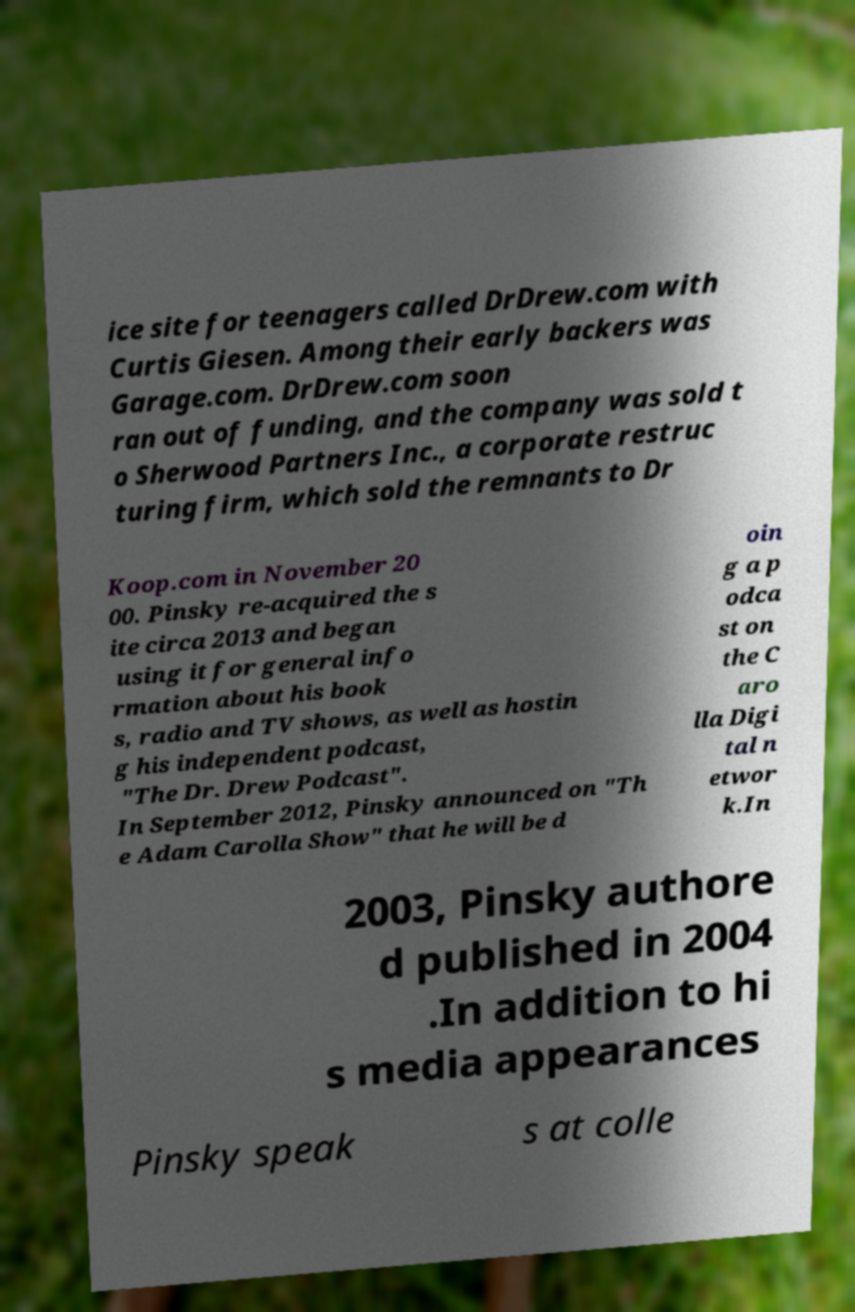Could you assist in decoding the text presented in this image and type it out clearly? ice site for teenagers called DrDrew.com with Curtis Giesen. Among their early backers was Garage.com. DrDrew.com soon ran out of funding, and the company was sold t o Sherwood Partners Inc., a corporate restruc turing firm, which sold the remnants to Dr Koop.com in November 20 00. Pinsky re-acquired the s ite circa 2013 and began using it for general info rmation about his book s, radio and TV shows, as well as hostin g his independent podcast, "The Dr. Drew Podcast". In September 2012, Pinsky announced on "Th e Adam Carolla Show" that he will be d oin g a p odca st on the C aro lla Digi tal n etwor k.In 2003, Pinsky authore d published in 2004 .In addition to hi s media appearances Pinsky speak s at colle 